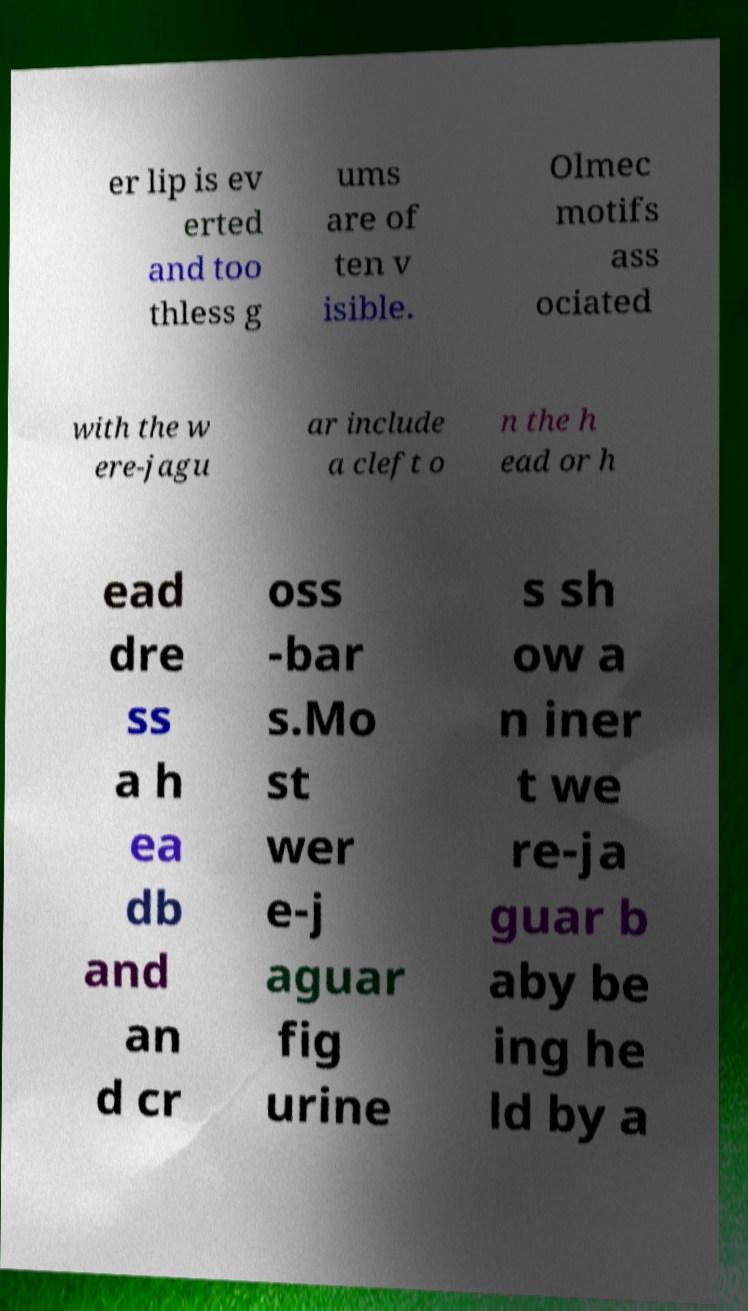Can you read and provide the text displayed in the image?This photo seems to have some interesting text. Can you extract and type it out for me? er lip is ev erted and too thless g ums are of ten v isible. Olmec motifs ass ociated with the w ere-jagu ar include a cleft o n the h ead or h ead dre ss a h ea db and an d cr oss -bar s.Mo st wer e-j aguar fig urine s sh ow a n iner t we re-ja guar b aby be ing he ld by a 